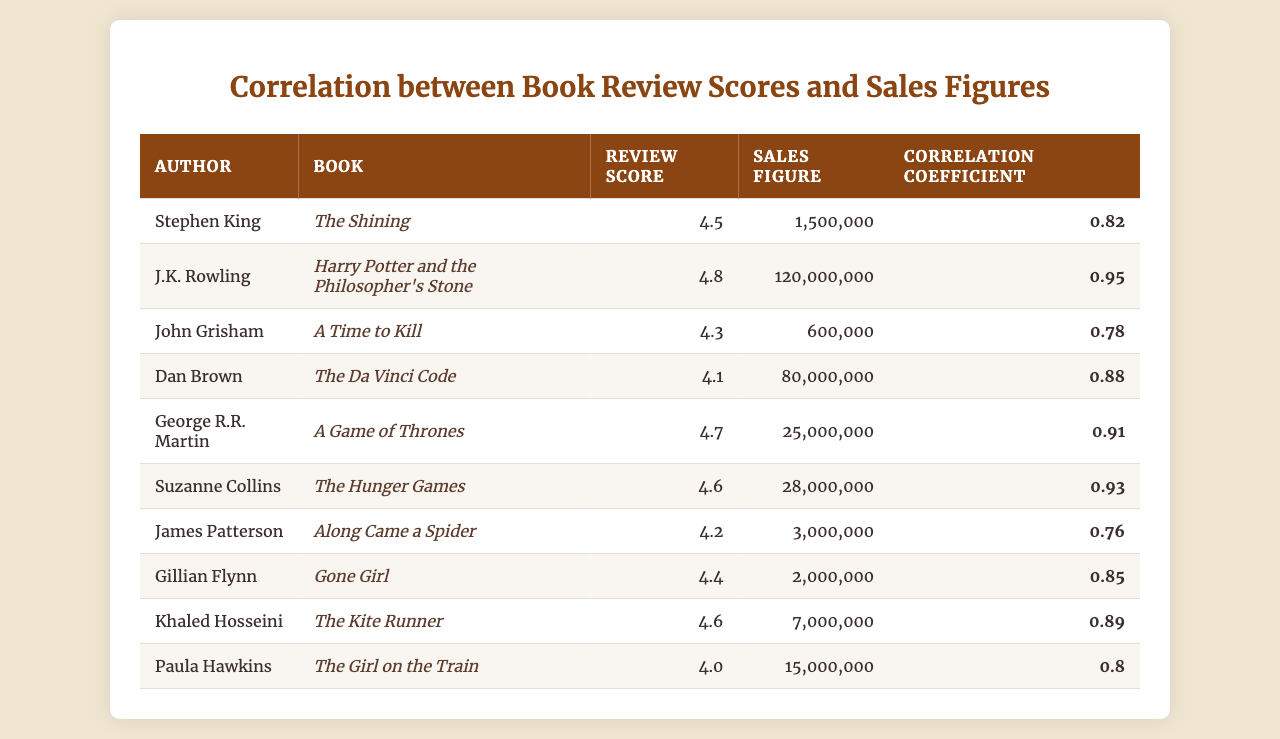What is the review score for "Harry Potter and the Philosopher's Stone"? The table indicates that the review score specifically associated with "Harry Potter and the Philosopher's Stone" under J.K. Rowling is 4.8.
Answer: 4.8 Which author has the highest sales figure? Reviewing the sales figures, J.K. Rowling's book has the highest sales figure at 120,000,000.
Answer: J.K. Rowling What is the correlation coefficient for "Gone Girl"? The correlation coefficient for "Gone Girl" associated with Gillian Flynn is listed as 0.85.
Answer: 0.85 What author has a review score of 4.6? The authors with a review score of 4.6 are Suzanne Collins and Khaled Hosseini.
Answer: Suzanne Collins, Khaled Hosseini What is the average review score of all authors? To find the average, sum the review scores (4.5 + 4.8 + 4.3 + 4.1 + 4.7 + 4.6 + 4.2 + 4.4 + 4.6 + 4.0 = 46.2) and divide by the total number of authors (46.2 / 10 = 4.62).
Answer: 4.62 Is there a positive correlation between review scores and sales figures? Given that all the correlation coefficients listed are above 0.7, this suggests a positive correlation exists between review scores and sales figures.
Answer: Yes Which book has a correlation coefficient closest to 0.80? The correlation coefficient for "The Girl on the Train" is 0.80, which is exactly 0.80.
Answer: The Girl on the Train How much higher are the sales figures for "The Da Vinci Code" compared to "A Time to Kill"? Sales figures for "The Da Vinci Code" are 80,000,000, and for "A Time to Kill" they are 600,000. The difference is 80,000,000 - 600,000 = 79,400,000.
Answer: 79,400,000 What is the total sales figure for the authors with a review score above 4.5? The authors with scores above 4.5 are Stephen King, J.K. Rowling, George R.R. Martin, Suzanne Collins, and Khaled Hosseini. Their sales figures total 1,500,000 + 120,000,000 + 25,000,000 + 28,000,000 + 7,000,000 = 181,500,000.
Answer: 181,500,000 Which author has the lowest review score among bestselling authors listed? The lowest review score is 4.0, which is associated with Paula Hawkins.
Answer: Paula Hawkins 